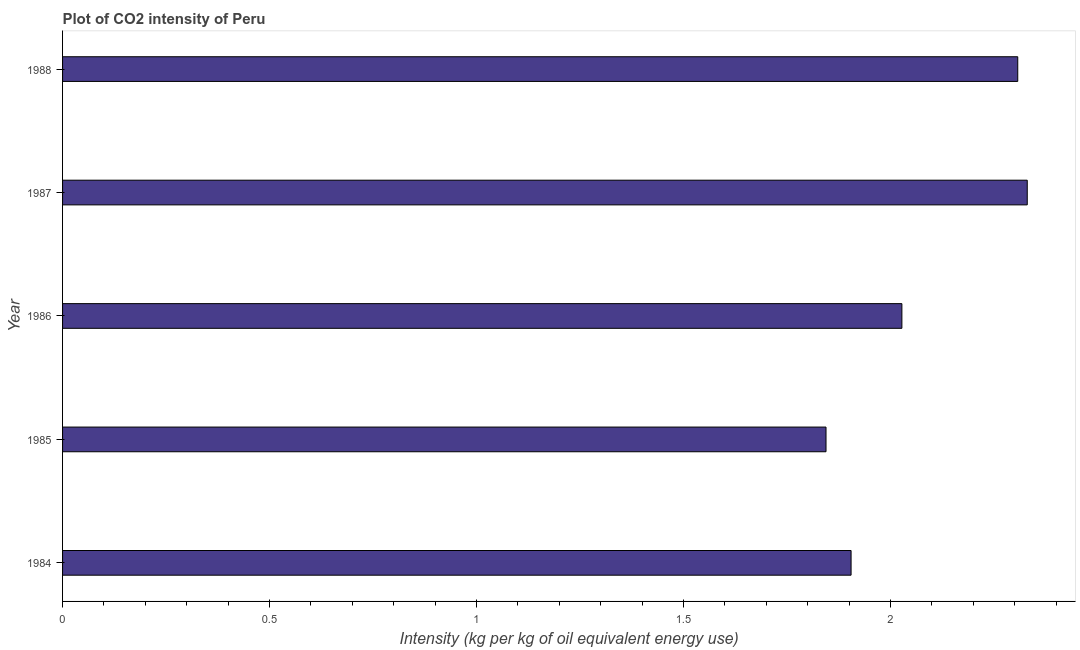Does the graph contain any zero values?
Offer a very short reply. No. Does the graph contain grids?
Offer a terse response. No. What is the title of the graph?
Provide a short and direct response. Plot of CO2 intensity of Peru. What is the label or title of the X-axis?
Give a very brief answer. Intensity (kg per kg of oil equivalent energy use). What is the co2 intensity in 1985?
Make the answer very short. 1.84. Across all years, what is the maximum co2 intensity?
Your answer should be compact. 2.33. Across all years, what is the minimum co2 intensity?
Ensure brevity in your answer.  1.84. In which year was the co2 intensity maximum?
Your response must be concise. 1987. In which year was the co2 intensity minimum?
Your answer should be compact. 1985. What is the sum of the co2 intensity?
Make the answer very short. 10.41. What is the difference between the co2 intensity in 1984 and 1985?
Your answer should be very brief. 0.06. What is the average co2 intensity per year?
Provide a succinct answer. 2.08. What is the median co2 intensity?
Ensure brevity in your answer.  2.03. What is the ratio of the co2 intensity in 1986 to that in 1987?
Make the answer very short. 0.87. What is the difference between the highest and the second highest co2 intensity?
Provide a short and direct response. 0.02. Is the sum of the co2 intensity in 1984 and 1988 greater than the maximum co2 intensity across all years?
Offer a terse response. Yes. What is the difference between the highest and the lowest co2 intensity?
Offer a very short reply. 0.49. In how many years, is the co2 intensity greater than the average co2 intensity taken over all years?
Your answer should be compact. 2. How many years are there in the graph?
Provide a succinct answer. 5. What is the Intensity (kg per kg of oil equivalent energy use) of 1984?
Your answer should be very brief. 1.9. What is the Intensity (kg per kg of oil equivalent energy use) of 1985?
Give a very brief answer. 1.84. What is the Intensity (kg per kg of oil equivalent energy use) in 1986?
Offer a terse response. 2.03. What is the Intensity (kg per kg of oil equivalent energy use) of 1987?
Your answer should be very brief. 2.33. What is the Intensity (kg per kg of oil equivalent energy use) in 1988?
Offer a terse response. 2.31. What is the difference between the Intensity (kg per kg of oil equivalent energy use) in 1984 and 1985?
Your response must be concise. 0.06. What is the difference between the Intensity (kg per kg of oil equivalent energy use) in 1984 and 1986?
Give a very brief answer. -0.12. What is the difference between the Intensity (kg per kg of oil equivalent energy use) in 1984 and 1987?
Ensure brevity in your answer.  -0.43. What is the difference between the Intensity (kg per kg of oil equivalent energy use) in 1984 and 1988?
Make the answer very short. -0.4. What is the difference between the Intensity (kg per kg of oil equivalent energy use) in 1985 and 1986?
Make the answer very short. -0.18. What is the difference between the Intensity (kg per kg of oil equivalent energy use) in 1985 and 1987?
Give a very brief answer. -0.49. What is the difference between the Intensity (kg per kg of oil equivalent energy use) in 1985 and 1988?
Make the answer very short. -0.46. What is the difference between the Intensity (kg per kg of oil equivalent energy use) in 1986 and 1987?
Make the answer very short. -0.3. What is the difference between the Intensity (kg per kg of oil equivalent energy use) in 1986 and 1988?
Your response must be concise. -0.28. What is the difference between the Intensity (kg per kg of oil equivalent energy use) in 1987 and 1988?
Provide a succinct answer. 0.02. What is the ratio of the Intensity (kg per kg of oil equivalent energy use) in 1984 to that in 1985?
Provide a succinct answer. 1.03. What is the ratio of the Intensity (kg per kg of oil equivalent energy use) in 1984 to that in 1986?
Offer a terse response. 0.94. What is the ratio of the Intensity (kg per kg of oil equivalent energy use) in 1984 to that in 1987?
Offer a very short reply. 0.82. What is the ratio of the Intensity (kg per kg of oil equivalent energy use) in 1984 to that in 1988?
Keep it short and to the point. 0.83. What is the ratio of the Intensity (kg per kg of oil equivalent energy use) in 1985 to that in 1986?
Provide a succinct answer. 0.91. What is the ratio of the Intensity (kg per kg of oil equivalent energy use) in 1985 to that in 1987?
Provide a succinct answer. 0.79. What is the ratio of the Intensity (kg per kg of oil equivalent energy use) in 1985 to that in 1988?
Your response must be concise. 0.8. What is the ratio of the Intensity (kg per kg of oil equivalent energy use) in 1986 to that in 1987?
Provide a succinct answer. 0.87. What is the ratio of the Intensity (kg per kg of oil equivalent energy use) in 1986 to that in 1988?
Provide a short and direct response. 0.88. 